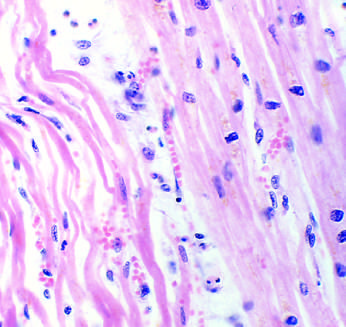re normal media for comparison separated by edema fluid?
Answer the question using a single word or phrase. No 